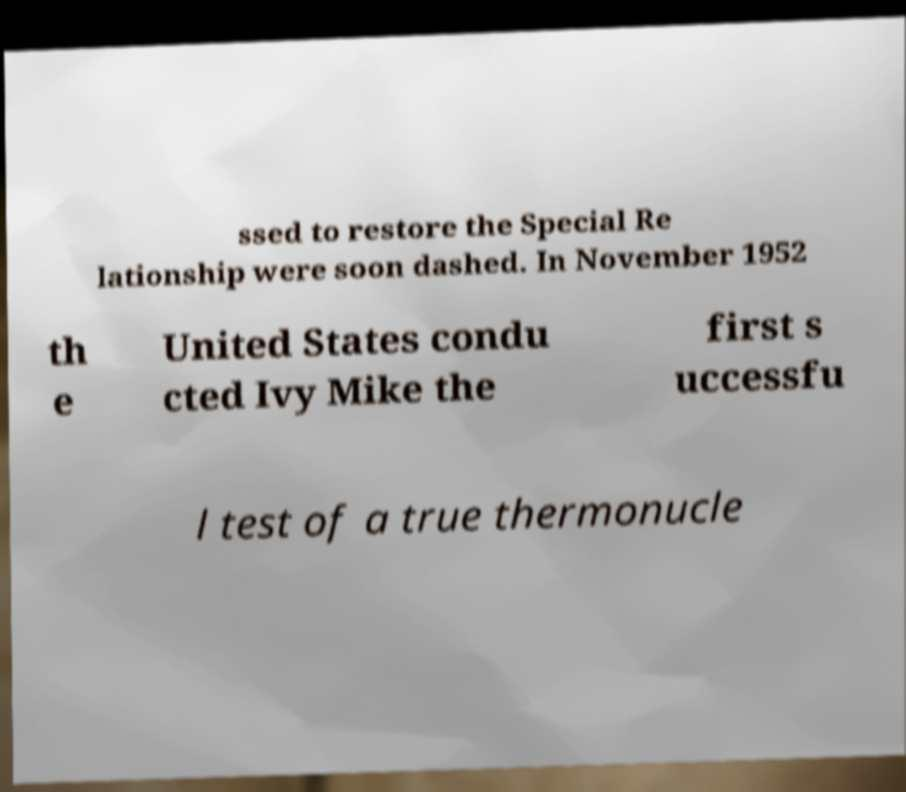Can you read and provide the text displayed in the image?This photo seems to have some interesting text. Can you extract and type it out for me? ssed to restore the Special Re lationship were soon dashed. In November 1952 th e United States condu cted Ivy Mike the first s uccessfu l test of a true thermonucle 